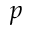Convert formula to latex. <formula><loc_0><loc_0><loc_500><loc_500>p</formula> 